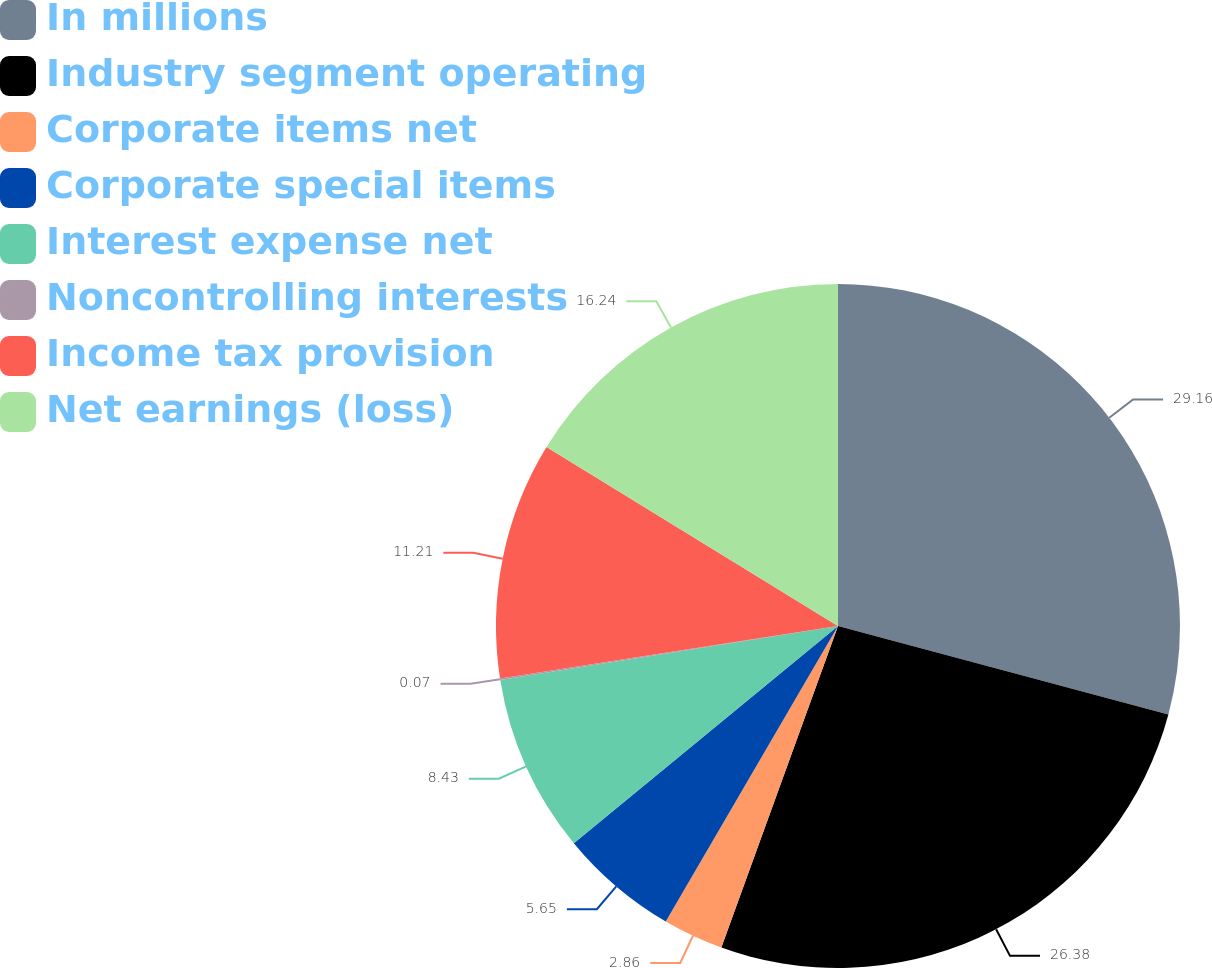<chart> <loc_0><loc_0><loc_500><loc_500><pie_chart><fcel>In millions<fcel>Industry segment operating<fcel>Corporate items net<fcel>Corporate special items<fcel>Interest expense net<fcel>Noncontrolling interests<fcel>Income tax provision<fcel>Net earnings (loss)<nl><fcel>29.16%<fcel>26.38%<fcel>2.86%<fcel>5.65%<fcel>8.43%<fcel>0.07%<fcel>11.21%<fcel>16.24%<nl></chart> 